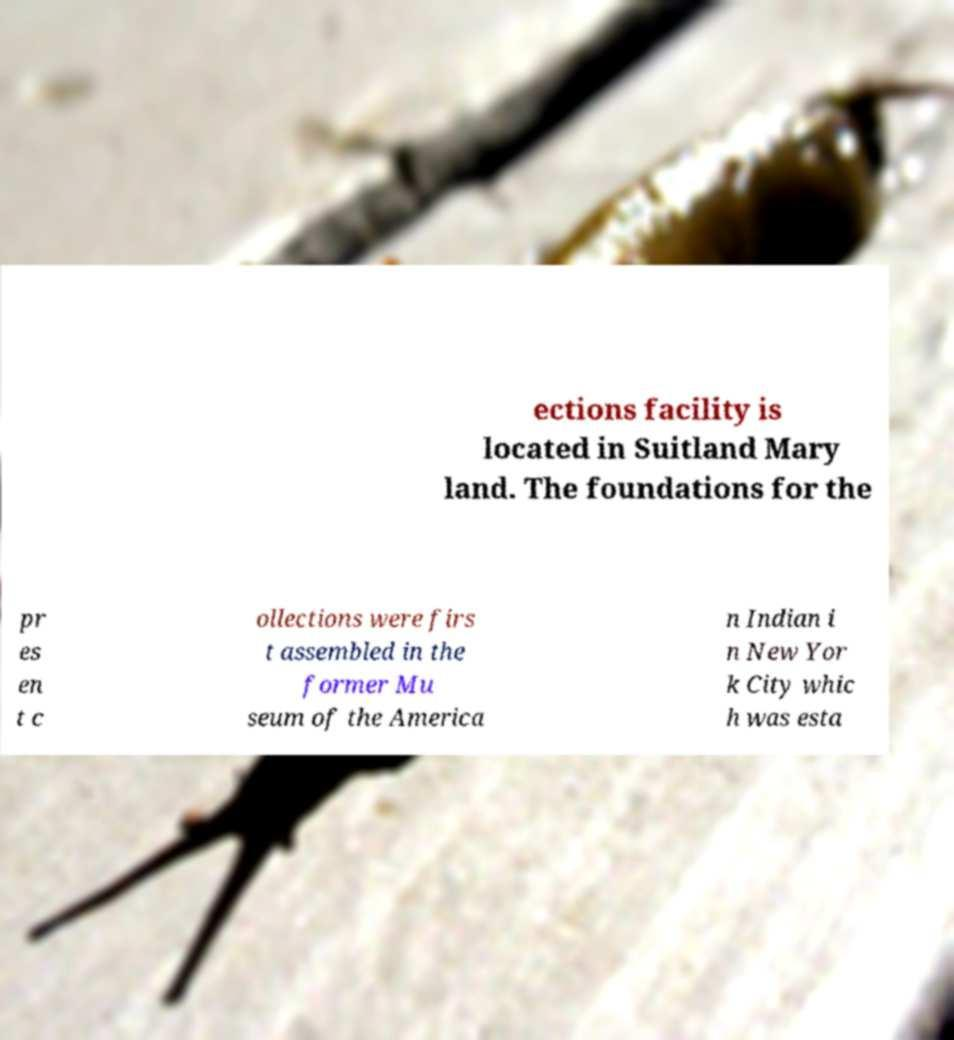Could you extract and type out the text from this image? ections facility is located in Suitland Mary land. The foundations for the pr es en t c ollections were firs t assembled in the former Mu seum of the America n Indian i n New Yor k City whic h was esta 